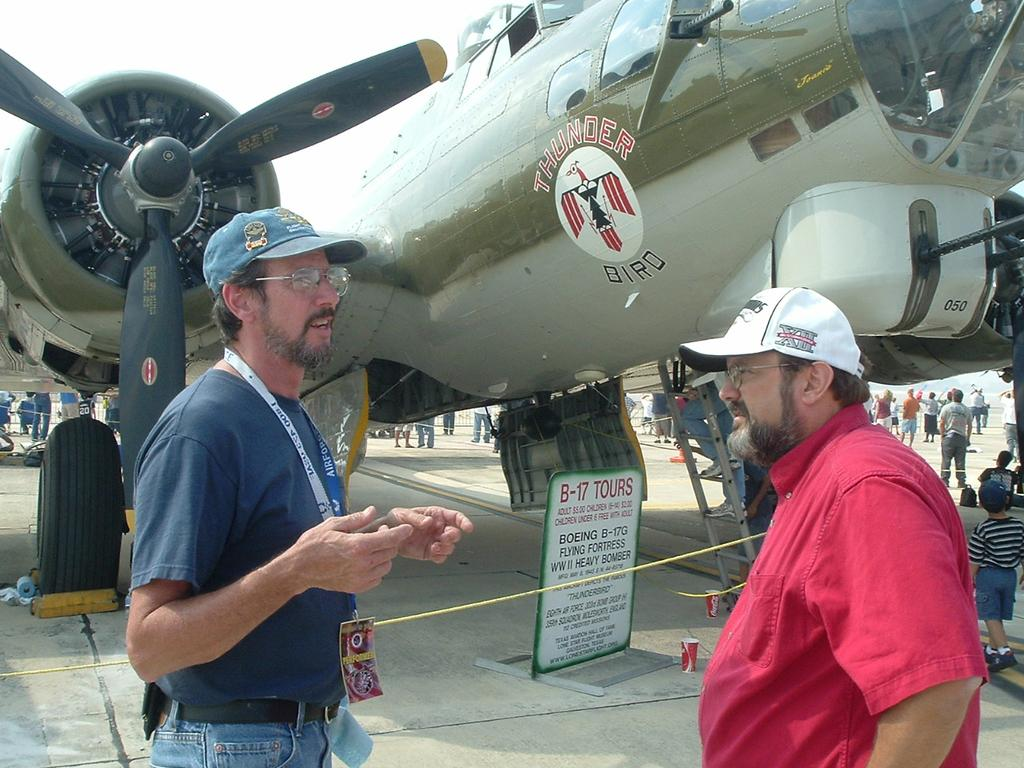<image>
Summarize the visual content of the image. Tow men stand in front of a green Thunder Bird jet 